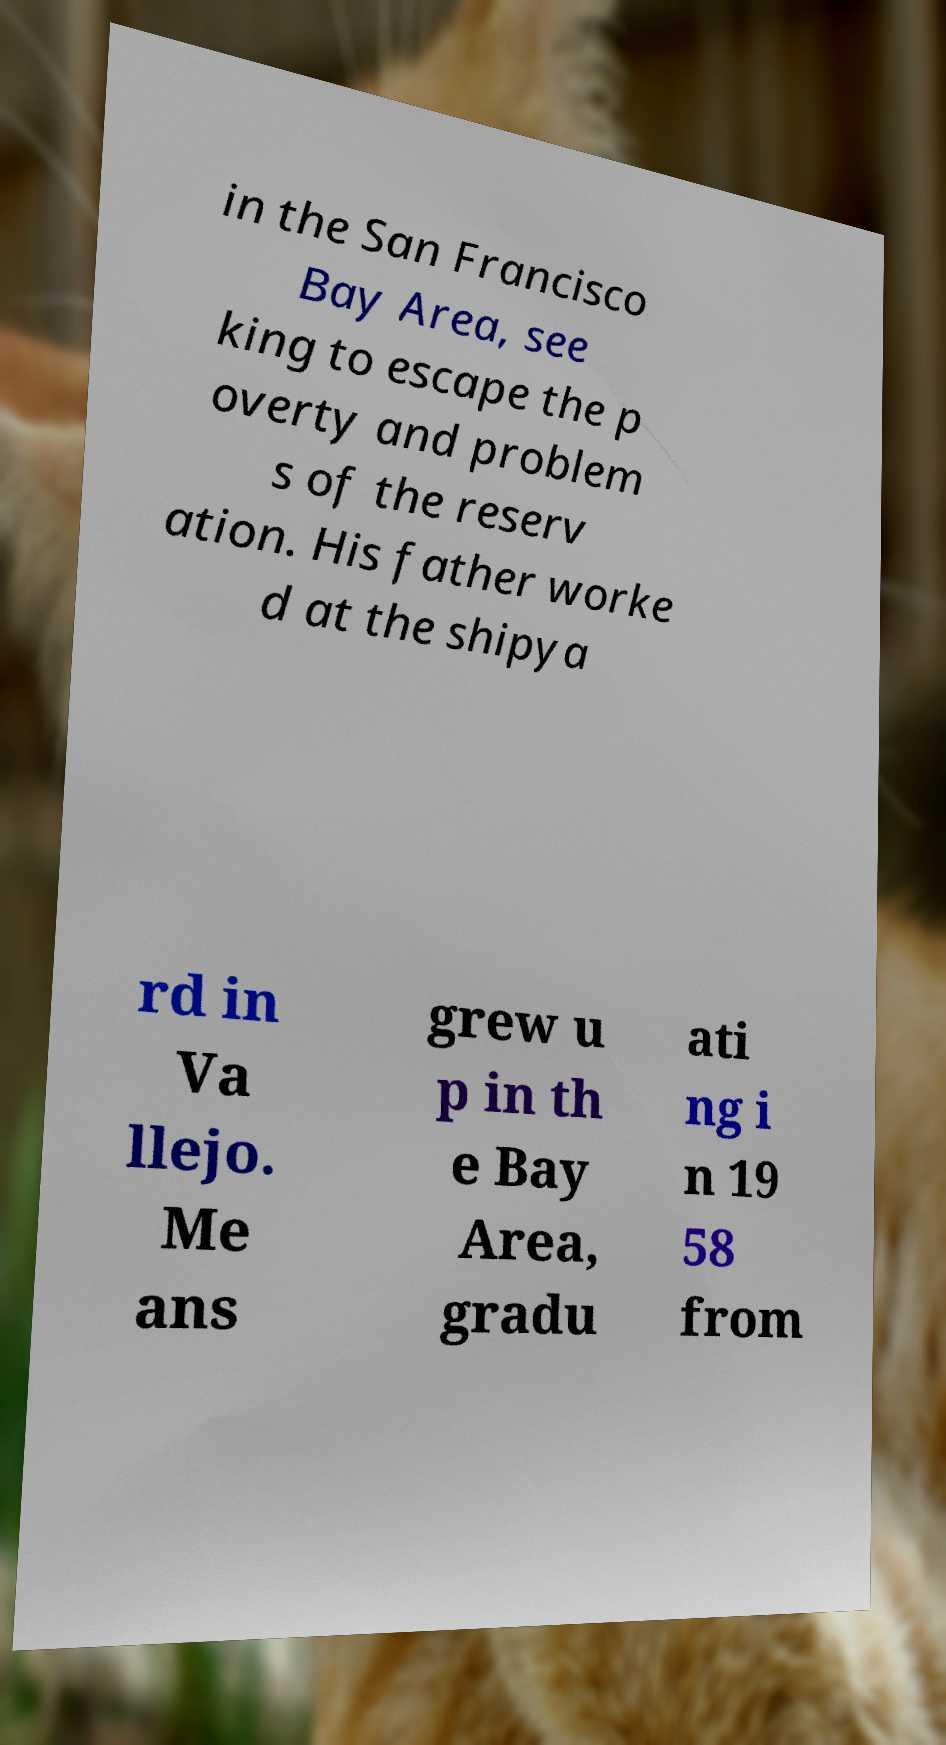For documentation purposes, I need the text within this image transcribed. Could you provide that? in the San Francisco Bay Area, see king to escape the p overty and problem s of the reserv ation. His father worke d at the shipya rd in Va llejo. Me ans grew u p in th e Bay Area, gradu ati ng i n 19 58 from 